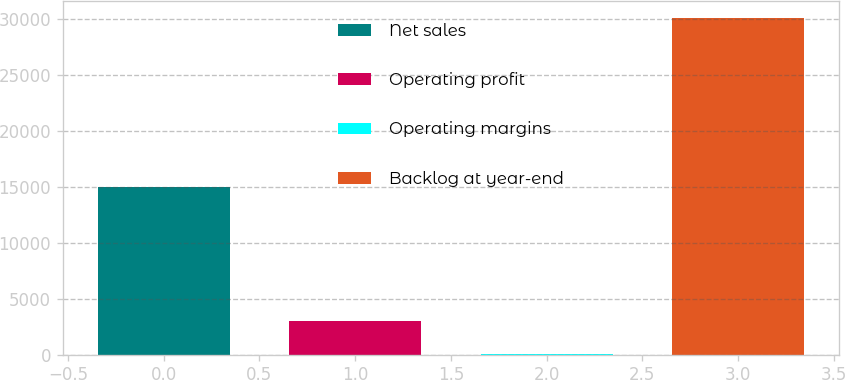<chart> <loc_0><loc_0><loc_500><loc_500><bar_chart><fcel>Net sales<fcel>Operating profit<fcel>Operating margins<fcel>Backlog at year-end<nl><fcel>14953<fcel>3020.26<fcel>11.4<fcel>30100<nl></chart> 